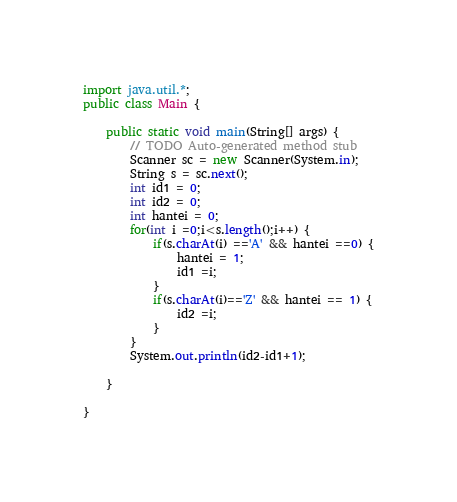<code> <loc_0><loc_0><loc_500><loc_500><_Java_>import java.util.*;
public class Main {

	public static void main(String[] args) {
		// TODO Auto-generated method stub
		Scanner sc = new Scanner(System.in);
		String s = sc.next();
		int id1 = 0;
		int id2 = 0;
		int hantei = 0;
		for(int i =0;i<s.length();i++) {
			if(s.charAt(i) =='A' && hantei ==0) {
				hantei = 1;
				id1 =i;
			}
			if(s.charAt(i)=='Z' && hantei == 1) {
				id2 =i;
			}
		}
		System.out.println(id2-id1+1);
		
	}

}

</code> 